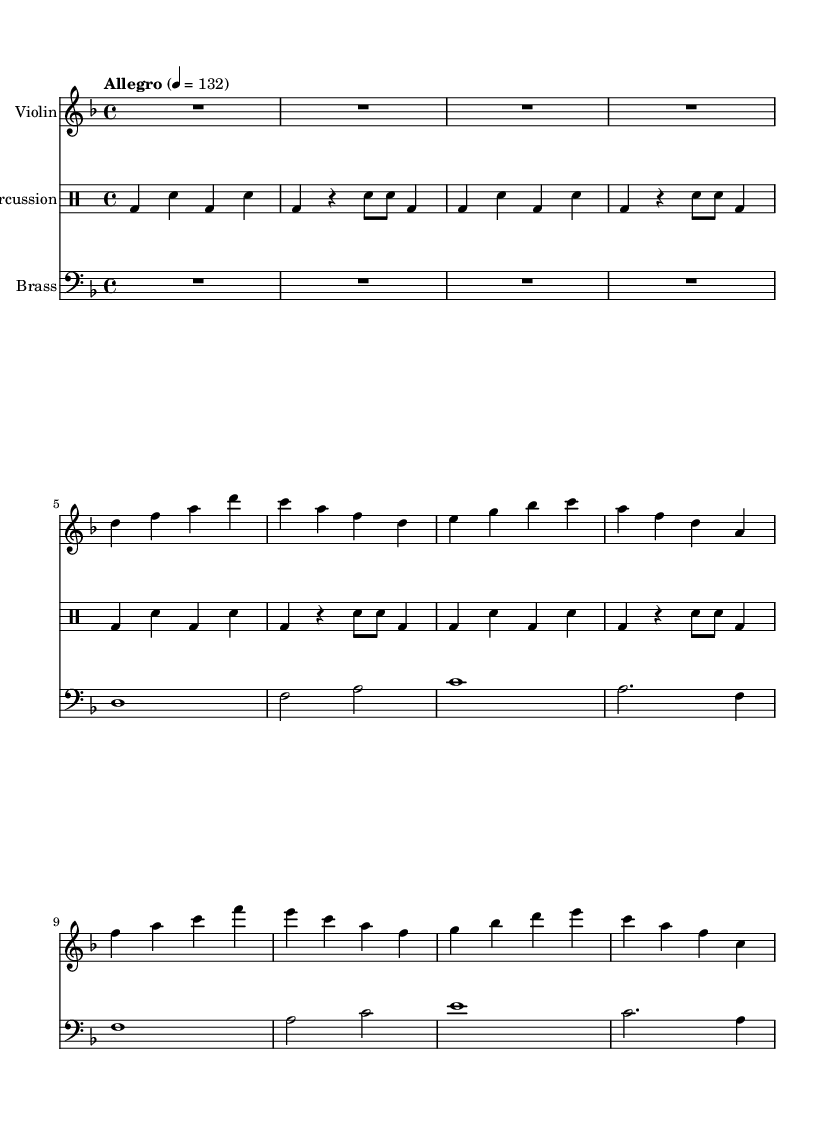What is the key signature of this music? The key signature is indicated at the beginning of the staff. It shows two flats, which corresponds to the key of D minor.
Answer: D minor What is the time signature of this music? The time signature is located at the beginning of the music, displaying a "4/4" notation, indicating four beats per measure with the quarter note getting the beat.
Answer: 4/4 What is the tempo marking of this piece? Tempo markings provide instructions on the speed of the music. Here it indicates "Allegro" and a metronome marking of 132 beats per minute.
Answer: Allegro How many measures are in the violin part? To find the number of measures, count each vertical line in the music. There are a total of 8 vertical lines for the violin part, indicating 8 measures.
Answer: 8 What type of percussion is used in this piece? The percussion part outlines typical drumming notation. The notation includes bass drum "bd" and snare "sn," indicating that those two types of percussion instruments are used.
Answer: Bass drum and snare What is the highest pitch note in the brass section? In the brass part, the notes are presented in pitch order. The highest pitch is identified as "f" with an octave indication, which appears at the beginning of the lower brass line.
Answer: f How often does the bass drum appear in the percussion part? By analyzing the percussion part, the bass drum appears every two beats within the measures, and it can be counted as 8 occurrences.
Answer: 8 